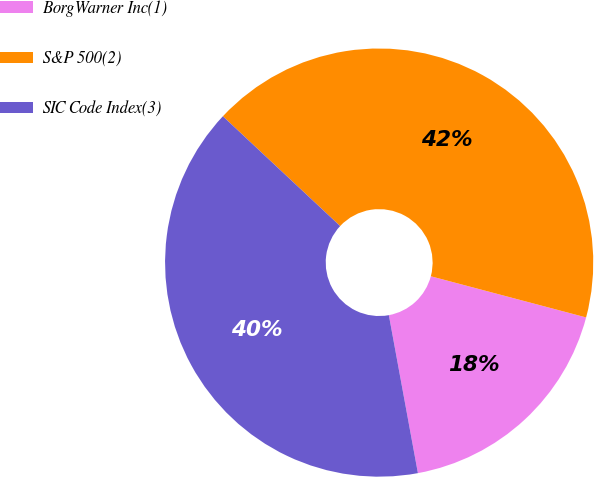Convert chart. <chart><loc_0><loc_0><loc_500><loc_500><pie_chart><fcel>BorgWarner Inc(1)<fcel>S&P 500(2)<fcel>SIC Code Index(3)<nl><fcel>17.98%<fcel>42.15%<fcel>39.87%<nl></chart> 